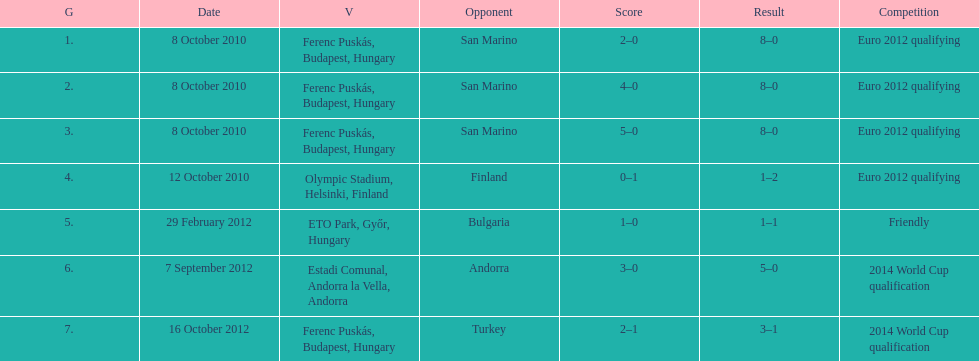Szalai scored only one more international goal against all other countries put together than he did against what one country? San Marino. 